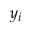Convert formula to latex. <formula><loc_0><loc_0><loc_500><loc_500>y _ { i }</formula> 